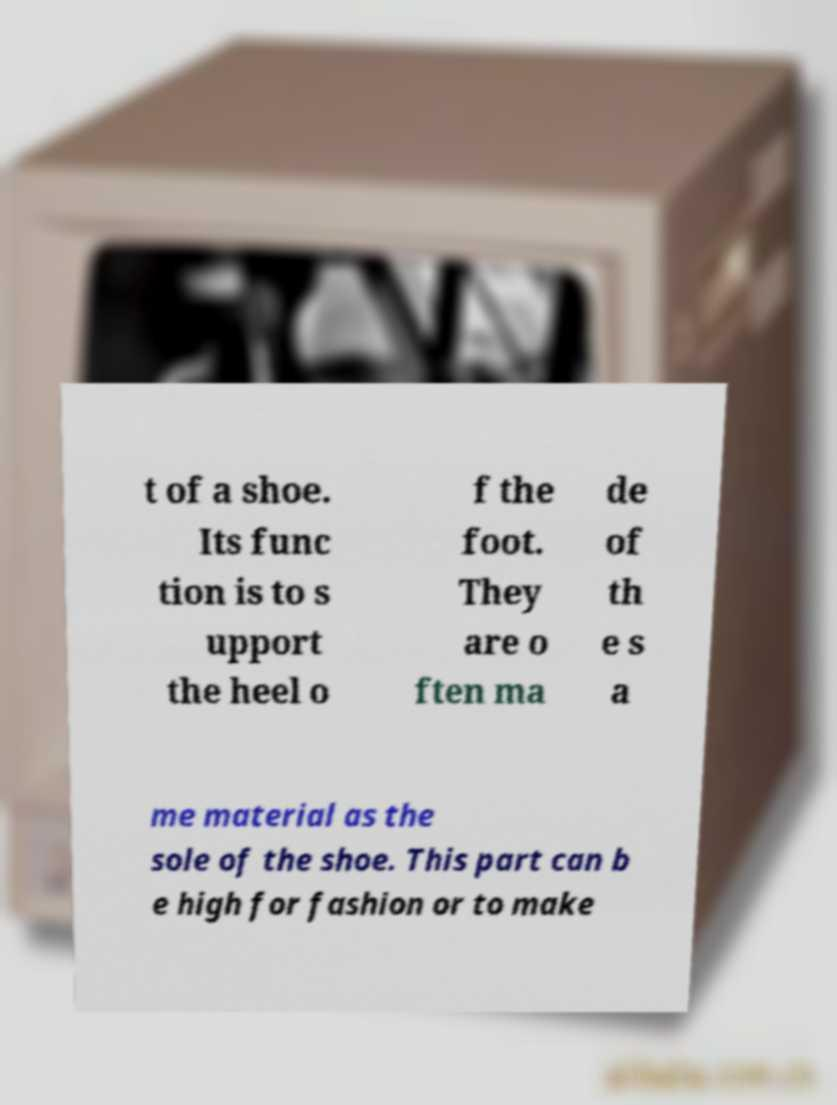For documentation purposes, I need the text within this image transcribed. Could you provide that? t of a shoe. Its func tion is to s upport the heel o f the foot. They are o ften ma de of th e s a me material as the sole of the shoe. This part can b e high for fashion or to make 